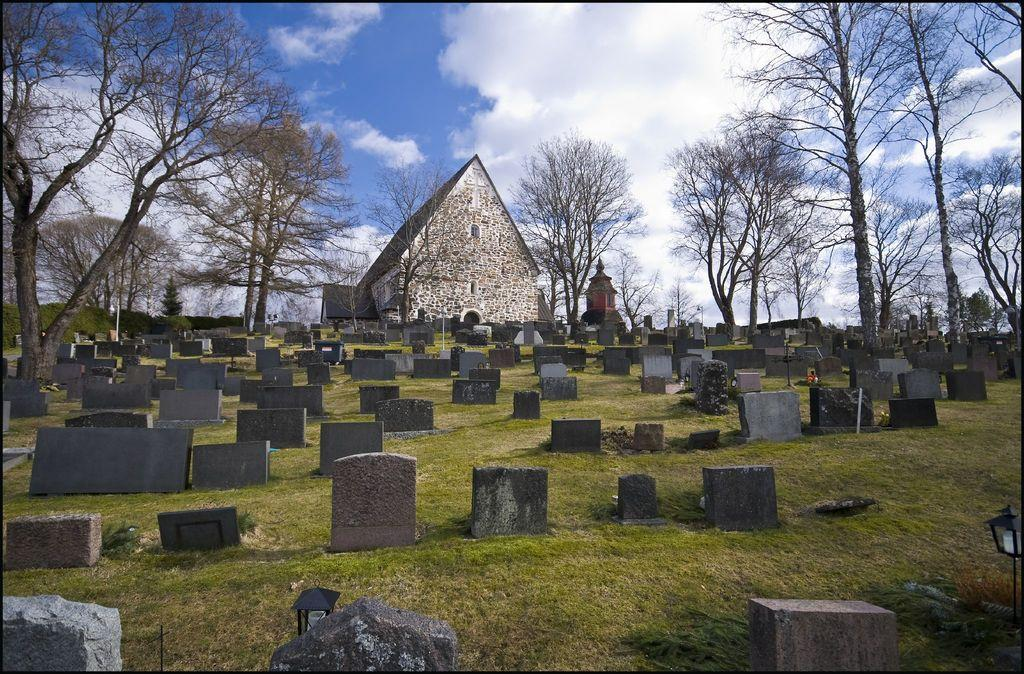Where was the image taken? The image was taken in a cemetery. What can be seen in the foreground of the image? There are gravestones in the foreground of the image. What is located in the center of the image? There are trees and a church in the center of the image. How would you describe the sky in the image? The sky is cloudy in the image. What type of camera is used to capture the scent in the image? There is no mention of a scent or camera in the image, so this question cannot be answered. 